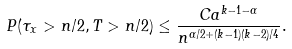<formula> <loc_0><loc_0><loc_500><loc_500>P ( \tau _ { x } > n / 2 , T > n / 2 ) \leq \frac { C a ^ { k - 1 - \alpha } } { n ^ { \alpha / 2 + ( k - 1 ) ( k - 2 ) / 4 } } .</formula> 